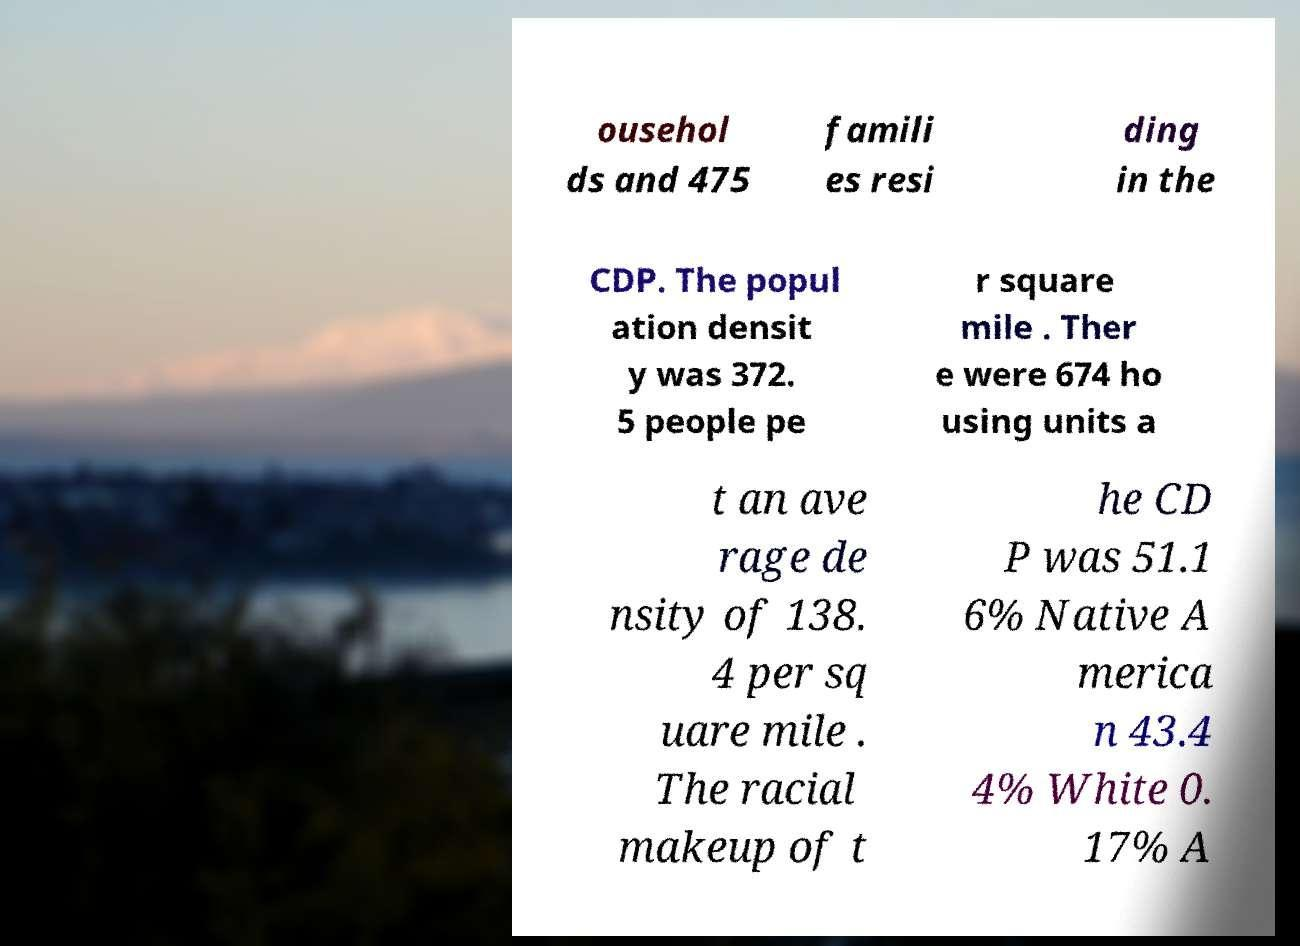I need the written content from this picture converted into text. Can you do that? ousehol ds and 475 famili es resi ding in the CDP. The popul ation densit y was 372. 5 people pe r square mile . Ther e were 674 ho using units a t an ave rage de nsity of 138. 4 per sq uare mile . The racial makeup of t he CD P was 51.1 6% Native A merica n 43.4 4% White 0. 17% A 